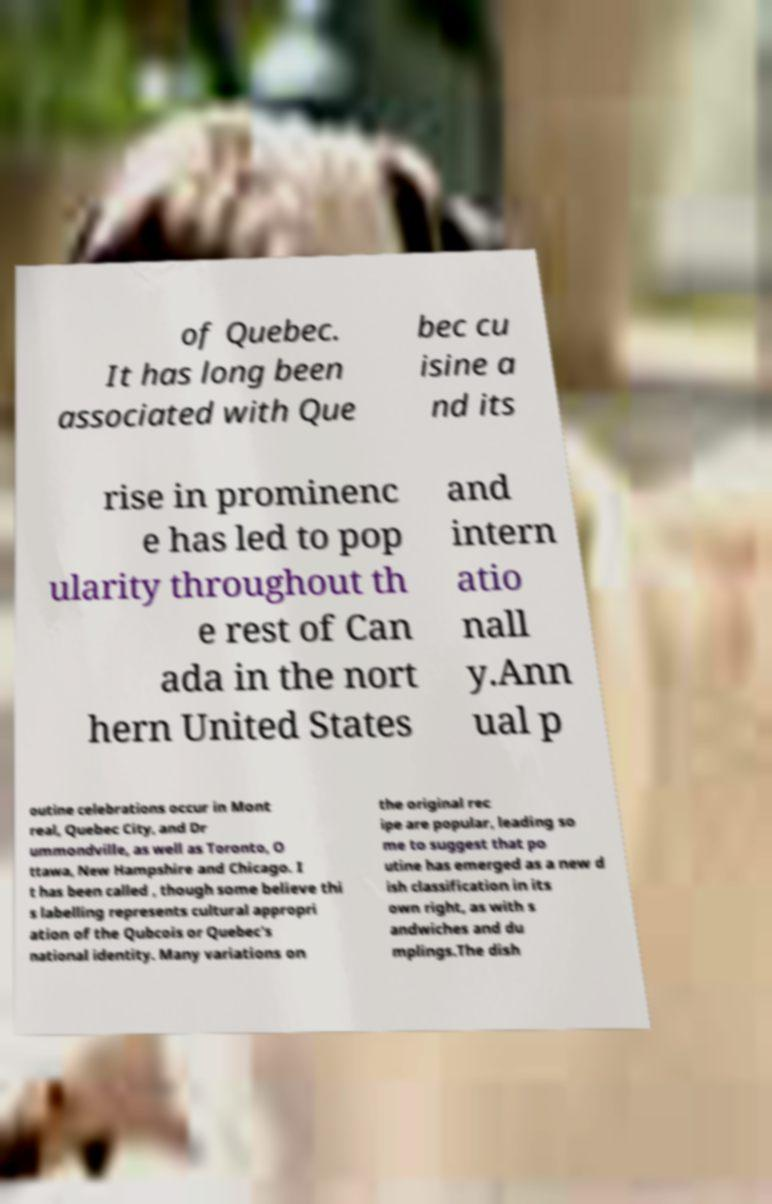I need the written content from this picture converted into text. Can you do that? of Quebec. It has long been associated with Que bec cu isine a nd its rise in prominenc e has led to pop ularity throughout th e rest of Can ada in the nort hern United States and intern atio nall y.Ann ual p outine celebrations occur in Mont real, Quebec City, and Dr ummondville, as well as Toronto, O ttawa, New Hampshire and Chicago. I t has been called , though some believe thi s labelling represents cultural appropri ation of the Qubcois or Quebec's national identity. Many variations on the original rec ipe are popular, leading so me to suggest that po utine has emerged as a new d ish classification in its own right, as with s andwiches and du mplings.The dish 